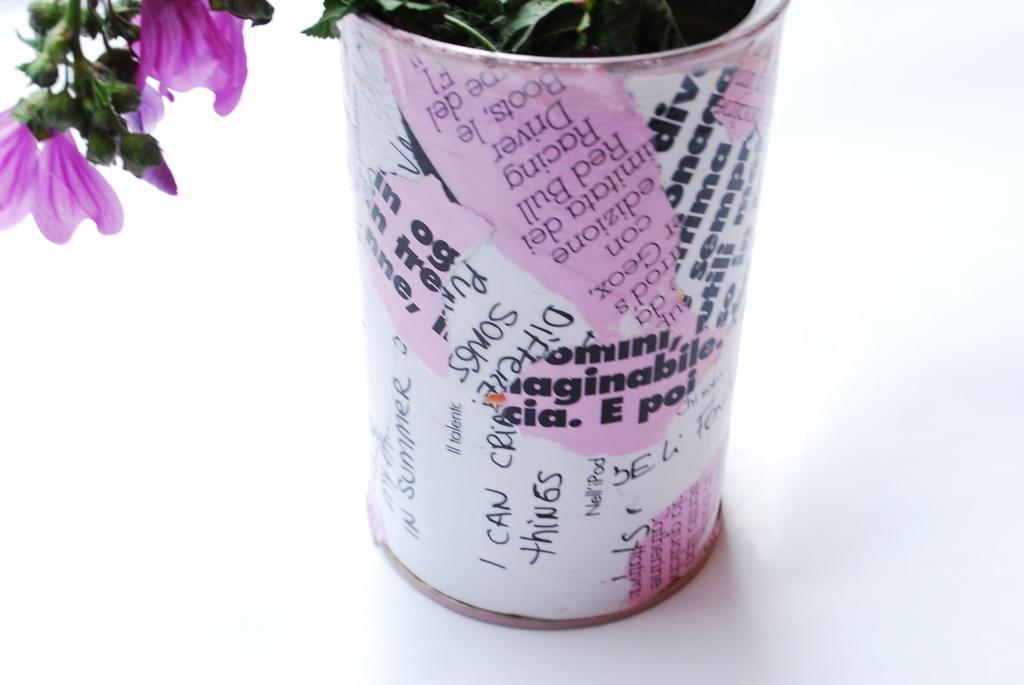Could you give a brief overview of what you see in this image? In the picture we can see a flower pot with some wordings on it with a pink color painting on it and in the pot we can see a plant with pink color flowers with petals and buds. 